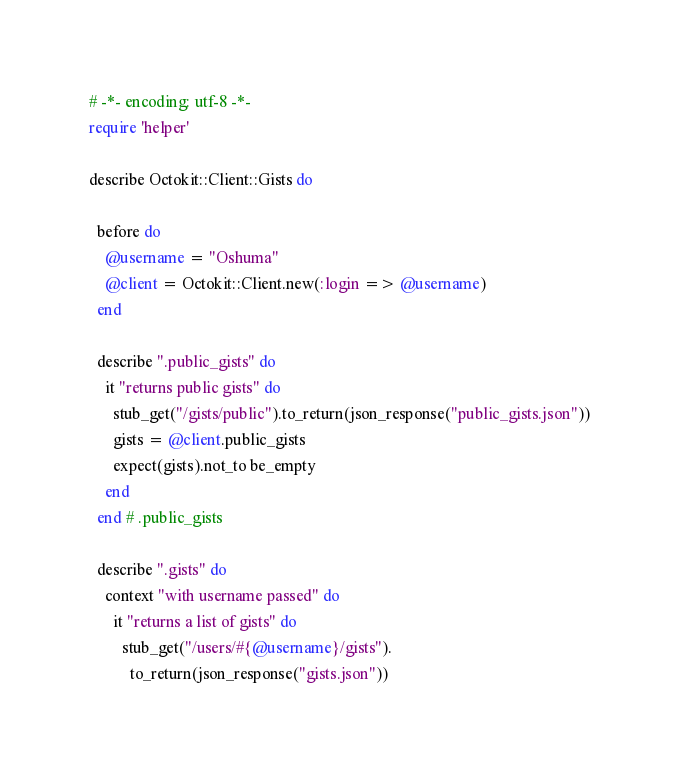<code> <loc_0><loc_0><loc_500><loc_500><_Ruby_># -*- encoding: utf-8 -*-
require 'helper'

describe Octokit::Client::Gists do

  before do
    @username = "Oshuma"
    @client = Octokit::Client.new(:login => @username)
  end

  describe ".public_gists" do
    it "returns public gists" do
      stub_get("/gists/public").to_return(json_response("public_gists.json"))
      gists = @client.public_gists
      expect(gists).not_to be_empty
    end
  end # .public_gists

  describe ".gists" do
    context "with username passed" do
      it "returns a list of gists" do
        stub_get("/users/#{@username}/gists").
          to_return(json_response("gists.json"))</code> 